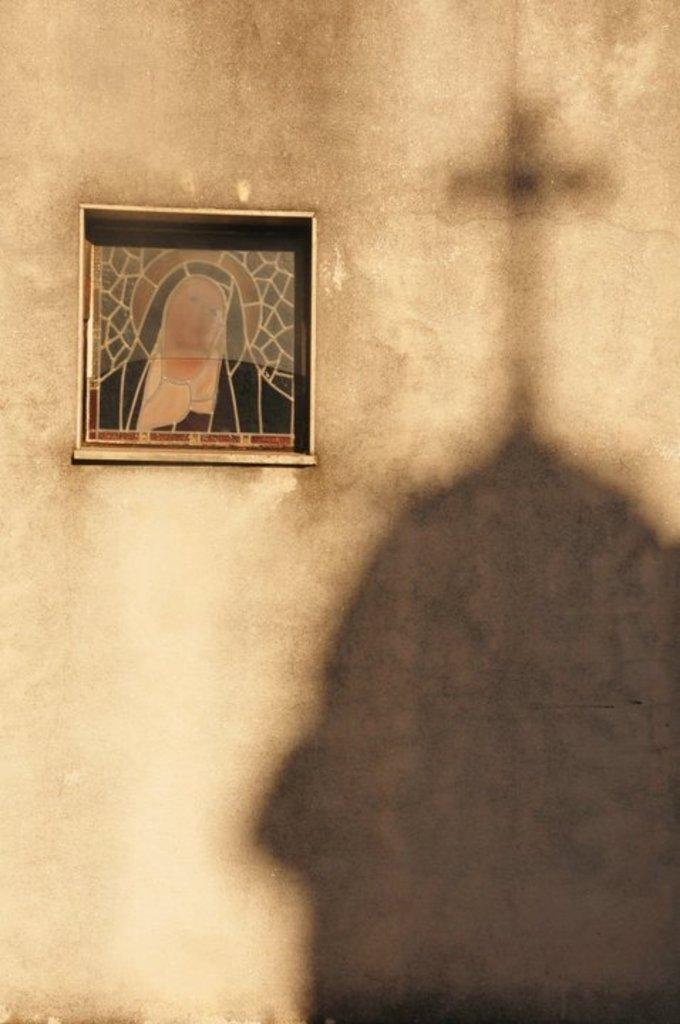Please provide a concise description of this image. In this picture I can see a frame on the wall and I can see shadow of a cross on the wall. 